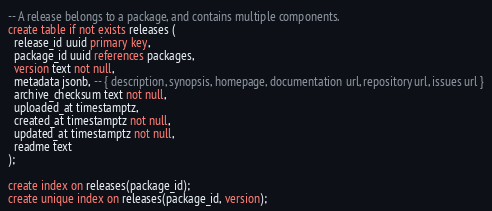Convert code to text. <code><loc_0><loc_0><loc_500><loc_500><_SQL_>-- A release belongs to a package, and contains multiple components.
create table if not exists releases (
  release_id uuid primary key,
  package_id uuid references packages,
  version text not null,
  metadata jsonb, -- { description, synopsis, homepage, documentation url, repository url, issues url }
  archive_checksum text not null,
  uploaded_at timestamptz,
  created_at timestamptz not null,
  updated_at timestamptz not null,
  readme text
);

create index on releases(package_id);
create unique index on releases(package_id, version);
</code> 